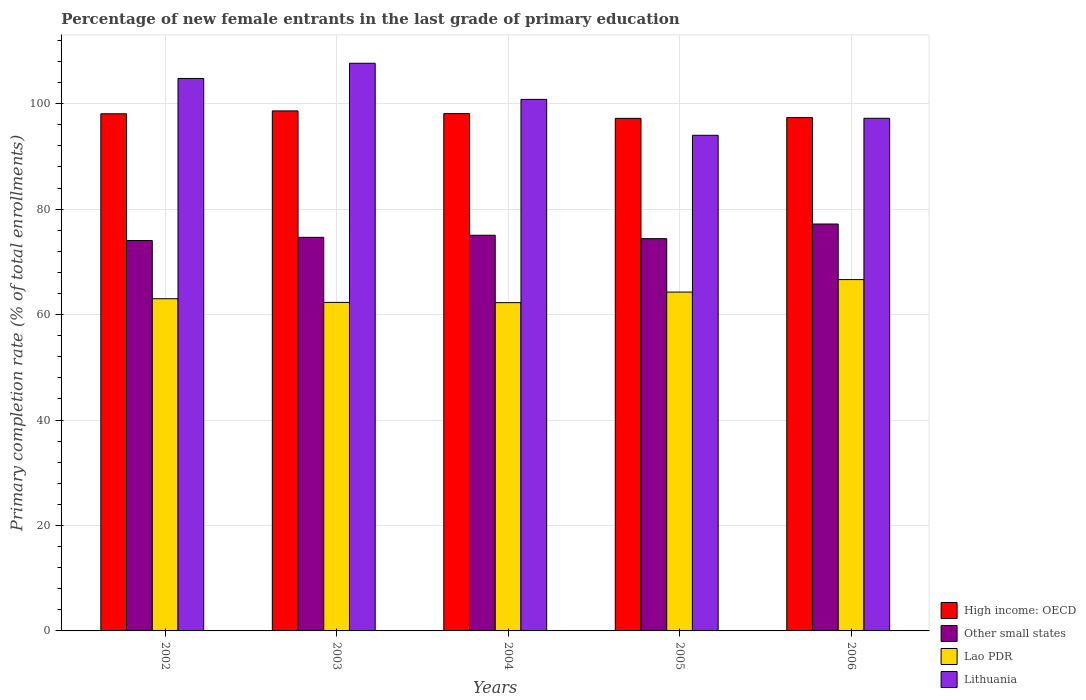How many bars are there on the 5th tick from the left?
Your answer should be compact. 4. How many bars are there on the 1st tick from the right?
Make the answer very short. 4. What is the label of the 5th group of bars from the left?
Your response must be concise. 2006. In how many cases, is the number of bars for a given year not equal to the number of legend labels?
Your response must be concise. 0. What is the percentage of new female entrants in Other small states in 2005?
Provide a short and direct response. 74.4. Across all years, what is the maximum percentage of new female entrants in Lao PDR?
Provide a succinct answer. 66.64. Across all years, what is the minimum percentage of new female entrants in High income: OECD?
Your answer should be compact. 97.22. In which year was the percentage of new female entrants in Other small states minimum?
Make the answer very short. 2002. What is the total percentage of new female entrants in Lao PDR in the graph?
Keep it short and to the point. 318.5. What is the difference between the percentage of new female entrants in Other small states in 2003 and that in 2006?
Keep it short and to the point. -2.53. What is the difference between the percentage of new female entrants in Other small states in 2003 and the percentage of new female entrants in Lao PDR in 2004?
Offer a very short reply. 12.39. What is the average percentage of new female entrants in Lithuania per year?
Your answer should be compact. 100.91. In the year 2006, what is the difference between the percentage of new female entrants in High income: OECD and percentage of new female entrants in Lithuania?
Your response must be concise. 0.13. In how many years, is the percentage of new female entrants in Lithuania greater than 8 %?
Give a very brief answer. 5. What is the ratio of the percentage of new female entrants in Other small states in 2003 to that in 2004?
Your response must be concise. 0.99. What is the difference between the highest and the second highest percentage of new female entrants in Other small states?
Offer a very short reply. 2.13. What is the difference between the highest and the lowest percentage of new female entrants in High income: OECD?
Your response must be concise. 1.41. Is it the case that in every year, the sum of the percentage of new female entrants in Other small states and percentage of new female entrants in Lao PDR is greater than the sum of percentage of new female entrants in Lithuania and percentage of new female entrants in High income: OECD?
Offer a very short reply. No. What does the 1st bar from the left in 2003 represents?
Give a very brief answer. High income: OECD. What does the 1st bar from the right in 2005 represents?
Keep it short and to the point. Lithuania. Is it the case that in every year, the sum of the percentage of new female entrants in Other small states and percentage of new female entrants in Lithuania is greater than the percentage of new female entrants in Lao PDR?
Offer a very short reply. Yes. How many bars are there?
Offer a terse response. 20. How many years are there in the graph?
Offer a terse response. 5. What is the difference between two consecutive major ticks on the Y-axis?
Provide a succinct answer. 20. Are the values on the major ticks of Y-axis written in scientific E-notation?
Offer a very short reply. No. Does the graph contain grids?
Your answer should be very brief. Yes. Where does the legend appear in the graph?
Your answer should be compact. Bottom right. How many legend labels are there?
Provide a short and direct response. 4. What is the title of the graph?
Offer a very short reply. Percentage of new female entrants in the last grade of primary education. What is the label or title of the Y-axis?
Offer a terse response. Primary completion rate (% of total enrollments). What is the Primary completion rate (% of total enrollments) of High income: OECD in 2002?
Your answer should be compact. 98.09. What is the Primary completion rate (% of total enrollments) in Other small states in 2002?
Offer a terse response. 74.05. What is the Primary completion rate (% of total enrollments) of Lao PDR in 2002?
Provide a short and direct response. 63.01. What is the Primary completion rate (% of total enrollments) in Lithuania in 2002?
Provide a short and direct response. 104.79. What is the Primary completion rate (% of total enrollments) of High income: OECD in 2003?
Give a very brief answer. 98.64. What is the Primary completion rate (% of total enrollments) in Other small states in 2003?
Provide a succinct answer. 74.66. What is the Primary completion rate (% of total enrollments) of Lao PDR in 2003?
Provide a short and direct response. 62.31. What is the Primary completion rate (% of total enrollments) in Lithuania in 2003?
Provide a short and direct response. 107.67. What is the Primary completion rate (% of total enrollments) of High income: OECD in 2004?
Your response must be concise. 98.12. What is the Primary completion rate (% of total enrollments) in Other small states in 2004?
Provide a short and direct response. 75.05. What is the Primary completion rate (% of total enrollments) in Lao PDR in 2004?
Offer a terse response. 62.27. What is the Primary completion rate (% of total enrollments) of Lithuania in 2004?
Offer a very short reply. 100.82. What is the Primary completion rate (% of total enrollments) of High income: OECD in 2005?
Your answer should be very brief. 97.22. What is the Primary completion rate (% of total enrollments) of Other small states in 2005?
Ensure brevity in your answer.  74.4. What is the Primary completion rate (% of total enrollments) in Lao PDR in 2005?
Keep it short and to the point. 64.27. What is the Primary completion rate (% of total enrollments) of Lithuania in 2005?
Your response must be concise. 94.01. What is the Primary completion rate (% of total enrollments) of High income: OECD in 2006?
Give a very brief answer. 97.37. What is the Primary completion rate (% of total enrollments) of Other small states in 2006?
Ensure brevity in your answer.  77.18. What is the Primary completion rate (% of total enrollments) of Lao PDR in 2006?
Make the answer very short. 66.64. What is the Primary completion rate (% of total enrollments) in Lithuania in 2006?
Offer a very short reply. 97.24. Across all years, what is the maximum Primary completion rate (% of total enrollments) of High income: OECD?
Provide a succinct answer. 98.64. Across all years, what is the maximum Primary completion rate (% of total enrollments) in Other small states?
Provide a succinct answer. 77.18. Across all years, what is the maximum Primary completion rate (% of total enrollments) of Lao PDR?
Make the answer very short. 66.64. Across all years, what is the maximum Primary completion rate (% of total enrollments) in Lithuania?
Offer a terse response. 107.67. Across all years, what is the minimum Primary completion rate (% of total enrollments) of High income: OECD?
Provide a short and direct response. 97.22. Across all years, what is the minimum Primary completion rate (% of total enrollments) in Other small states?
Keep it short and to the point. 74.05. Across all years, what is the minimum Primary completion rate (% of total enrollments) in Lao PDR?
Your answer should be very brief. 62.27. Across all years, what is the minimum Primary completion rate (% of total enrollments) of Lithuania?
Offer a terse response. 94.01. What is the total Primary completion rate (% of total enrollments) of High income: OECD in the graph?
Provide a succinct answer. 489.44. What is the total Primary completion rate (% of total enrollments) in Other small states in the graph?
Your answer should be compact. 375.34. What is the total Primary completion rate (% of total enrollments) of Lao PDR in the graph?
Make the answer very short. 318.5. What is the total Primary completion rate (% of total enrollments) of Lithuania in the graph?
Keep it short and to the point. 504.54. What is the difference between the Primary completion rate (% of total enrollments) of High income: OECD in 2002 and that in 2003?
Your response must be concise. -0.55. What is the difference between the Primary completion rate (% of total enrollments) of Other small states in 2002 and that in 2003?
Your response must be concise. -0.61. What is the difference between the Primary completion rate (% of total enrollments) of Lao PDR in 2002 and that in 2003?
Your answer should be very brief. 0.7. What is the difference between the Primary completion rate (% of total enrollments) of Lithuania in 2002 and that in 2003?
Keep it short and to the point. -2.88. What is the difference between the Primary completion rate (% of total enrollments) in High income: OECD in 2002 and that in 2004?
Offer a terse response. -0.03. What is the difference between the Primary completion rate (% of total enrollments) in Other small states in 2002 and that in 2004?
Your answer should be compact. -1. What is the difference between the Primary completion rate (% of total enrollments) in Lao PDR in 2002 and that in 2004?
Make the answer very short. 0.74. What is the difference between the Primary completion rate (% of total enrollments) in Lithuania in 2002 and that in 2004?
Make the answer very short. 3.97. What is the difference between the Primary completion rate (% of total enrollments) in High income: OECD in 2002 and that in 2005?
Your answer should be compact. 0.87. What is the difference between the Primary completion rate (% of total enrollments) in Other small states in 2002 and that in 2005?
Give a very brief answer. -0.35. What is the difference between the Primary completion rate (% of total enrollments) of Lao PDR in 2002 and that in 2005?
Your answer should be compact. -1.26. What is the difference between the Primary completion rate (% of total enrollments) in Lithuania in 2002 and that in 2005?
Your answer should be very brief. 10.78. What is the difference between the Primary completion rate (% of total enrollments) of High income: OECD in 2002 and that in 2006?
Your answer should be very brief. 0.72. What is the difference between the Primary completion rate (% of total enrollments) in Other small states in 2002 and that in 2006?
Your response must be concise. -3.14. What is the difference between the Primary completion rate (% of total enrollments) in Lao PDR in 2002 and that in 2006?
Your answer should be very brief. -3.63. What is the difference between the Primary completion rate (% of total enrollments) in Lithuania in 2002 and that in 2006?
Ensure brevity in your answer.  7.55. What is the difference between the Primary completion rate (% of total enrollments) in High income: OECD in 2003 and that in 2004?
Your response must be concise. 0.52. What is the difference between the Primary completion rate (% of total enrollments) of Other small states in 2003 and that in 2004?
Give a very brief answer. -0.4. What is the difference between the Primary completion rate (% of total enrollments) of Lao PDR in 2003 and that in 2004?
Provide a succinct answer. 0.05. What is the difference between the Primary completion rate (% of total enrollments) in Lithuania in 2003 and that in 2004?
Your answer should be very brief. 6.85. What is the difference between the Primary completion rate (% of total enrollments) in High income: OECD in 2003 and that in 2005?
Give a very brief answer. 1.41. What is the difference between the Primary completion rate (% of total enrollments) in Other small states in 2003 and that in 2005?
Your response must be concise. 0.25. What is the difference between the Primary completion rate (% of total enrollments) of Lao PDR in 2003 and that in 2005?
Provide a succinct answer. -1.96. What is the difference between the Primary completion rate (% of total enrollments) in Lithuania in 2003 and that in 2005?
Your response must be concise. 13.66. What is the difference between the Primary completion rate (% of total enrollments) in High income: OECD in 2003 and that in 2006?
Provide a succinct answer. 1.27. What is the difference between the Primary completion rate (% of total enrollments) in Other small states in 2003 and that in 2006?
Your answer should be very brief. -2.53. What is the difference between the Primary completion rate (% of total enrollments) in Lao PDR in 2003 and that in 2006?
Your answer should be compact. -4.33. What is the difference between the Primary completion rate (% of total enrollments) of Lithuania in 2003 and that in 2006?
Give a very brief answer. 10.44. What is the difference between the Primary completion rate (% of total enrollments) of High income: OECD in 2004 and that in 2005?
Provide a short and direct response. 0.9. What is the difference between the Primary completion rate (% of total enrollments) of Other small states in 2004 and that in 2005?
Provide a succinct answer. 0.65. What is the difference between the Primary completion rate (% of total enrollments) in Lao PDR in 2004 and that in 2005?
Provide a short and direct response. -2.01. What is the difference between the Primary completion rate (% of total enrollments) of Lithuania in 2004 and that in 2005?
Make the answer very short. 6.81. What is the difference between the Primary completion rate (% of total enrollments) in High income: OECD in 2004 and that in 2006?
Keep it short and to the point. 0.75. What is the difference between the Primary completion rate (% of total enrollments) in Other small states in 2004 and that in 2006?
Offer a terse response. -2.13. What is the difference between the Primary completion rate (% of total enrollments) in Lao PDR in 2004 and that in 2006?
Give a very brief answer. -4.37. What is the difference between the Primary completion rate (% of total enrollments) of Lithuania in 2004 and that in 2006?
Offer a very short reply. 3.58. What is the difference between the Primary completion rate (% of total enrollments) of High income: OECD in 2005 and that in 2006?
Provide a succinct answer. -0.15. What is the difference between the Primary completion rate (% of total enrollments) in Other small states in 2005 and that in 2006?
Offer a very short reply. -2.78. What is the difference between the Primary completion rate (% of total enrollments) in Lao PDR in 2005 and that in 2006?
Your answer should be very brief. -2.37. What is the difference between the Primary completion rate (% of total enrollments) in Lithuania in 2005 and that in 2006?
Your response must be concise. -3.23. What is the difference between the Primary completion rate (% of total enrollments) in High income: OECD in 2002 and the Primary completion rate (% of total enrollments) in Other small states in 2003?
Your answer should be very brief. 23.43. What is the difference between the Primary completion rate (% of total enrollments) in High income: OECD in 2002 and the Primary completion rate (% of total enrollments) in Lao PDR in 2003?
Provide a short and direct response. 35.78. What is the difference between the Primary completion rate (% of total enrollments) in High income: OECD in 2002 and the Primary completion rate (% of total enrollments) in Lithuania in 2003?
Provide a short and direct response. -9.58. What is the difference between the Primary completion rate (% of total enrollments) of Other small states in 2002 and the Primary completion rate (% of total enrollments) of Lao PDR in 2003?
Make the answer very short. 11.74. What is the difference between the Primary completion rate (% of total enrollments) of Other small states in 2002 and the Primary completion rate (% of total enrollments) of Lithuania in 2003?
Your answer should be very brief. -33.63. What is the difference between the Primary completion rate (% of total enrollments) of Lao PDR in 2002 and the Primary completion rate (% of total enrollments) of Lithuania in 2003?
Ensure brevity in your answer.  -44.66. What is the difference between the Primary completion rate (% of total enrollments) in High income: OECD in 2002 and the Primary completion rate (% of total enrollments) in Other small states in 2004?
Your answer should be very brief. 23.04. What is the difference between the Primary completion rate (% of total enrollments) of High income: OECD in 2002 and the Primary completion rate (% of total enrollments) of Lao PDR in 2004?
Provide a succinct answer. 35.82. What is the difference between the Primary completion rate (% of total enrollments) in High income: OECD in 2002 and the Primary completion rate (% of total enrollments) in Lithuania in 2004?
Keep it short and to the point. -2.73. What is the difference between the Primary completion rate (% of total enrollments) in Other small states in 2002 and the Primary completion rate (% of total enrollments) in Lao PDR in 2004?
Offer a very short reply. 11.78. What is the difference between the Primary completion rate (% of total enrollments) in Other small states in 2002 and the Primary completion rate (% of total enrollments) in Lithuania in 2004?
Provide a succinct answer. -26.77. What is the difference between the Primary completion rate (% of total enrollments) of Lao PDR in 2002 and the Primary completion rate (% of total enrollments) of Lithuania in 2004?
Ensure brevity in your answer.  -37.81. What is the difference between the Primary completion rate (% of total enrollments) in High income: OECD in 2002 and the Primary completion rate (% of total enrollments) in Other small states in 2005?
Your answer should be very brief. 23.69. What is the difference between the Primary completion rate (% of total enrollments) of High income: OECD in 2002 and the Primary completion rate (% of total enrollments) of Lao PDR in 2005?
Offer a very short reply. 33.82. What is the difference between the Primary completion rate (% of total enrollments) of High income: OECD in 2002 and the Primary completion rate (% of total enrollments) of Lithuania in 2005?
Keep it short and to the point. 4.08. What is the difference between the Primary completion rate (% of total enrollments) of Other small states in 2002 and the Primary completion rate (% of total enrollments) of Lao PDR in 2005?
Give a very brief answer. 9.78. What is the difference between the Primary completion rate (% of total enrollments) of Other small states in 2002 and the Primary completion rate (% of total enrollments) of Lithuania in 2005?
Provide a succinct answer. -19.96. What is the difference between the Primary completion rate (% of total enrollments) of Lao PDR in 2002 and the Primary completion rate (% of total enrollments) of Lithuania in 2005?
Provide a succinct answer. -31. What is the difference between the Primary completion rate (% of total enrollments) in High income: OECD in 2002 and the Primary completion rate (% of total enrollments) in Other small states in 2006?
Your response must be concise. 20.91. What is the difference between the Primary completion rate (% of total enrollments) of High income: OECD in 2002 and the Primary completion rate (% of total enrollments) of Lao PDR in 2006?
Ensure brevity in your answer.  31.45. What is the difference between the Primary completion rate (% of total enrollments) of High income: OECD in 2002 and the Primary completion rate (% of total enrollments) of Lithuania in 2006?
Your answer should be compact. 0.85. What is the difference between the Primary completion rate (% of total enrollments) in Other small states in 2002 and the Primary completion rate (% of total enrollments) in Lao PDR in 2006?
Ensure brevity in your answer.  7.41. What is the difference between the Primary completion rate (% of total enrollments) in Other small states in 2002 and the Primary completion rate (% of total enrollments) in Lithuania in 2006?
Give a very brief answer. -23.19. What is the difference between the Primary completion rate (% of total enrollments) of Lao PDR in 2002 and the Primary completion rate (% of total enrollments) of Lithuania in 2006?
Ensure brevity in your answer.  -34.23. What is the difference between the Primary completion rate (% of total enrollments) in High income: OECD in 2003 and the Primary completion rate (% of total enrollments) in Other small states in 2004?
Your answer should be very brief. 23.58. What is the difference between the Primary completion rate (% of total enrollments) in High income: OECD in 2003 and the Primary completion rate (% of total enrollments) in Lao PDR in 2004?
Offer a very short reply. 36.37. What is the difference between the Primary completion rate (% of total enrollments) in High income: OECD in 2003 and the Primary completion rate (% of total enrollments) in Lithuania in 2004?
Offer a very short reply. -2.18. What is the difference between the Primary completion rate (% of total enrollments) of Other small states in 2003 and the Primary completion rate (% of total enrollments) of Lao PDR in 2004?
Give a very brief answer. 12.39. What is the difference between the Primary completion rate (% of total enrollments) of Other small states in 2003 and the Primary completion rate (% of total enrollments) of Lithuania in 2004?
Your answer should be compact. -26.17. What is the difference between the Primary completion rate (% of total enrollments) in Lao PDR in 2003 and the Primary completion rate (% of total enrollments) in Lithuania in 2004?
Make the answer very short. -38.51. What is the difference between the Primary completion rate (% of total enrollments) in High income: OECD in 2003 and the Primary completion rate (% of total enrollments) in Other small states in 2005?
Give a very brief answer. 24.24. What is the difference between the Primary completion rate (% of total enrollments) in High income: OECD in 2003 and the Primary completion rate (% of total enrollments) in Lao PDR in 2005?
Provide a short and direct response. 34.37. What is the difference between the Primary completion rate (% of total enrollments) in High income: OECD in 2003 and the Primary completion rate (% of total enrollments) in Lithuania in 2005?
Offer a very short reply. 4.63. What is the difference between the Primary completion rate (% of total enrollments) in Other small states in 2003 and the Primary completion rate (% of total enrollments) in Lao PDR in 2005?
Give a very brief answer. 10.38. What is the difference between the Primary completion rate (% of total enrollments) in Other small states in 2003 and the Primary completion rate (% of total enrollments) in Lithuania in 2005?
Provide a succinct answer. -19.36. What is the difference between the Primary completion rate (% of total enrollments) in Lao PDR in 2003 and the Primary completion rate (% of total enrollments) in Lithuania in 2005?
Your answer should be very brief. -31.7. What is the difference between the Primary completion rate (% of total enrollments) in High income: OECD in 2003 and the Primary completion rate (% of total enrollments) in Other small states in 2006?
Offer a terse response. 21.45. What is the difference between the Primary completion rate (% of total enrollments) of High income: OECD in 2003 and the Primary completion rate (% of total enrollments) of Lao PDR in 2006?
Give a very brief answer. 32. What is the difference between the Primary completion rate (% of total enrollments) in High income: OECD in 2003 and the Primary completion rate (% of total enrollments) in Lithuania in 2006?
Give a very brief answer. 1.4. What is the difference between the Primary completion rate (% of total enrollments) of Other small states in 2003 and the Primary completion rate (% of total enrollments) of Lao PDR in 2006?
Keep it short and to the point. 8.02. What is the difference between the Primary completion rate (% of total enrollments) of Other small states in 2003 and the Primary completion rate (% of total enrollments) of Lithuania in 2006?
Provide a succinct answer. -22.58. What is the difference between the Primary completion rate (% of total enrollments) of Lao PDR in 2003 and the Primary completion rate (% of total enrollments) of Lithuania in 2006?
Make the answer very short. -34.92. What is the difference between the Primary completion rate (% of total enrollments) in High income: OECD in 2004 and the Primary completion rate (% of total enrollments) in Other small states in 2005?
Provide a succinct answer. 23.72. What is the difference between the Primary completion rate (% of total enrollments) of High income: OECD in 2004 and the Primary completion rate (% of total enrollments) of Lao PDR in 2005?
Offer a very short reply. 33.85. What is the difference between the Primary completion rate (% of total enrollments) of High income: OECD in 2004 and the Primary completion rate (% of total enrollments) of Lithuania in 2005?
Offer a very short reply. 4.11. What is the difference between the Primary completion rate (% of total enrollments) of Other small states in 2004 and the Primary completion rate (% of total enrollments) of Lao PDR in 2005?
Your answer should be very brief. 10.78. What is the difference between the Primary completion rate (% of total enrollments) in Other small states in 2004 and the Primary completion rate (% of total enrollments) in Lithuania in 2005?
Offer a terse response. -18.96. What is the difference between the Primary completion rate (% of total enrollments) in Lao PDR in 2004 and the Primary completion rate (% of total enrollments) in Lithuania in 2005?
Keep it short and to the point. -31.75. What is the difference between the Primary completion rate (% of total enrollments) in High income: OECD in 2004 and the Primary completion rate (% of total enrollments) in Other small states in 2006?
Give a very brief answer. 20.94. What is the difference between the Primary completion rate (% of total enrollments) of High income: OECD in 2004 and the Primary completion rate (% of total enrollments) of Lao PDR in 2006?
Give a very brief answer. 31.48. What is the difference between the Primary completion rate (% of total enrollments) in High income: OECD in 2004 and the Primary completion rate (% of total enrollments) in Lithuania in 2006?
Make the answer very short. 0.88. What is the difference between the Primary completion rate (% of total enrollments) in Other small states in 2004 and the Primary completion rate (% of total enrollments) in Lao PDR in 2006?
Your response must be concise. 8.41. What is the difference between the Primary completion rate (% of total enrollments) of Other small states in 2004 and the Primary completion rate (% of total enrollments) of Lithuania in 2006?
Offer a terse response. -22.18. What is the difference between the Primary completion rate (% of total enrollments) of Lao PDR in 2004 and the Primary completion rate (% of total enrollments) of Lithuania in 2006?
Make the answer very short. -34.97. What is the difference between the Primary completion rate (% of total enrollments) in High income: OECD in 2005 and the Primary completion rate (% of total enrollments) in Other small states in 2006?
Provide a succinct answer. 20.04. What is the difference between the Primary completion rate (% of total enrollments) of High income: OECD in 2005 and the Primary completion rate (% of total enrollments) of Lao PDR in 2006?
Your response must be concise. 30.58. What is the difference between the Primary completion rate (% of total enrollments) in High income: OECD in 2005 and the Primary completion rate (% of total enrollments) in Lithuania in 2006?
Your answer should be very brief. -0.01. What is the difference between the Primary completion rate (% of total enrollments) of Other small states in 2005 and the Primary completion rate (% of total enrollments) of Lao PDR in 2006?
Provide a succinct answer. 7.76. What is the difference between the Primary completion rate (% of total enrollments) in Other small states in 2005 and the Primary completion rate (% of total enrollments) in Lithuania in 2006?
Provide a succinct answer. -22.84. What is the difference between the Primary completion rate (% of total enrollments) of Lao PDR in 2005 and the Primary completion rate (% of total enrollments) of Lithuania in 2006?
Ensure brevity in your answer.  -32.97. What is the average Primary completion rate (% of total enrollments) of High income: OECD per year?
Offer a very short reply. 97.89. What is the average Primary completion rate (% of total enrollments) in Other small states per year?
Your answer should be very brief. 75.07. What is the average Primary completion rate (% of total enrollments) in Lao PDR per year?
Your answer should be compact. 63.7. What is the average Primary completion rate (% of total enrollments) in Lithuania per year?
Your answer should be compact. 100.91. In the year 2002, what is the difference between the Primary completion rate (% of total enrollments) in High income: OECD and Primary completion rate (% of total enrollments) in Other small states?
Your response must be concise. 24.04. In the year 2002, what is the difference between the Primary completion rate (% of total enrollments) of High income: OECD and Primary completion rate (% of total enrollments) of Lao PDR?
Offer a very short reply. 35.08. In the year 2002, what is the difference between the Primary completion rate (% of total enrollments) of High income: OECD and Primary completion rate (% of total enrollments) of Lithuania?
Give a very brief answer. -6.7. In the year 2002, what is the difference between the Primary completion rate (% of total enrollments) in Other small states and Primary completion rate (% of total enrollments) in Lao PDR?
Provide a succinct answer. 11.04. In the year 2002, what is the difference between the Primary completion rate (% of total enrollments) of Other small states and Primary completion rate (% of total enrollments) of Lithuania?
Your response must be concise. -30.74. In the year 2002, what is the difference between the Primary completion rate (% of total enrollments) of Lao PDR and Primary completion rate (% of total enrollments) of Lithuania?
Give a very brief answer. -41.78. In the year 2003, what is the difference between the Primary completion rate (% of total enrollments) in High income: OECD and Primary completion rate (% of total enrollments) in Other small states?
Your response must be concise. 23.98. In the year 2003, what is the difference between the Primary completion rate (% of total enrollments) of High income: OECD and Primary completion rate (% of total enrollments) of Lao PDR?
Provide a short and direct response. 36.32. In the year 2003, what is the difference between the Primary completion rate (% of total enrollments) in High income: OECD and Primary completion rate (% of total enrollments) in Lithuania?
Your answer should be very brief. -9.04. In the year 2003, what is the difference between the Primary completion rate (% of total enrollments) in Other small states and Primary completion rate (% of total enrollments) in Lao PDR?
Ensure brevity in your answer.  12.34. In the year 2003, what is the difference between the Primary completion rate (% of total enrollments) of Other small states and Primary completion rate (% of total enrollments) of Lithuania?
Keep it short and to the point. -33.02. In the year 2003, what is the difference between the Primary completion rate (% of total enrollments) in Lao PDR and Primary completion rate (% of total enrollments) in Lithuania?
Offer a terse response. -45.36. In the year 2004, what is the difference between the Primary completion rate (% of total enrollments) of High income: OECD and Primary completion rate (% of total enrollments) of Other small states?
Your answer should be compact. 23.07. In the year 2004, what is the difference between the Primary completion rate (% of total enrollments) of High income: OECD and Primary completion rate (% of total enrollments) of Lao PDR?
Provide a short and direct response. 35.86. In the year 2004, what is the difference between the Primary completion rate (% of total enrollments) in High income: OECD and Primary completion rate (% of total enrollments) in Lithuania?
Provide a succinct answer. -2.7. In the year 2004, what is the difference between the Primary completion rate (% of total enrollments) of Other small states and Primary completion rate (% of total enrollments) of Lao PDR?
Keep it short and to the point. 12.79. In the year 2004, what is the difference between the Primary completion rate (% of total enrollments) in Other small states and Primary completion rate (% of total enrollments) in Lithuania?
Your answer should be very brief. -25.77. In the year 2004, what is the difference between the Primary completion rate (% of total enrollments) of Lao PDR and Primary completion rate (% of total enrollments) of Lithuania?
Keep it short and to the point. -38.56. In the year 2005, what is the difference between the Primary completion rate (% of total enrollments) in High income: OECD and Primary completion rate (% of total enrollments) in Other small states?
Ensure brevity in your answer.  22.82. In the year 2005, what is the difference between the Primary completion rate (% of total enrollments) of High income: OECD and Primary completion rate (% of total enrollments) of Lao PDR?
Your answer should be very brief. 32.95. In the year 2005, what is the difference between the Primary completion rate (% of total enrollments) of High income: OECD and Primary completion rate (% of total enrollments) of Lithuania?
Provide a succinct answer. 3.21. In the year 2005, what is the difference between the Primary completion rate (% of total enrollments) of Other small states and Primary completion rate (% of total enrollments) of Lao PDR?
Offer a terse response. 10.13. In the year 2005, what is the difference between the Primary completion rate (% of total enrollments) in Other small states and Primary completion rate (% of total enrollments) in Lithuania?
Your answer should be compact. -19.61. In the year 2005, what is the difference between the Primary completion rate (% of total enrollments) in Lao PDR and Primary completion rate (% of total enrollments) in Lithuania?
Your response must be concise. -29.74. In the year 2006, what is the difference between the Primary completion rate (% of total enrollments) in High income: OECD and Primary completion rate (% of total enrollments) in Other small states?
Your response must be concise. 20.19. In the year 2006, what is the difference between the Primary completion rate (% of total enrollments) in High income: OECD and Primary completion rate (% of total enrollments) in Lao PDR?
Make the answer very short. 30.73. In the year 2006, what is the difference between the Primary completion rate (% of total enrollments) in High income: OECD and Primary completion rate (% of total enrollments) in Lithuania?
Provide a short and direct response. 0.13. In the year 2006, what is the difference between the Primary completion rate (% of total enrollments) in Other small states and Primary completion rate (% of total enrollments) in Lao PDR?
Keep it short and to the point. 10.54. In the year 2006, what is the difference between the Primary completion rate (% of total enrollments) of Other small states and Primary completion rate (% of total enrollments) of Lithuania?
Give a very brief answer. -20.05. In the year 2006, what is the difference between the Primary completion rate (% of total enrollments) of Lao PDR and Primary completion rate (% of total enrollments) of Lithuania?
Keep it short and to the point. -30.6. What is the ratio of the Primary completion rate (% of total enrollments) in High income: OECD in 2002 to that in 2003?
Provide a succinct answer. 0.99. What is the ratio of the Primary completion rate (% of total enrollments) of Other small states in 2002 to that in 2003?
Give a very brief answer. 0.99. What is the ratio of the Primary completion rate (% of total enrollments) of Lao PDR in 2002 to that in 2003?
Give a very brief answer. 1.01. What is the ratio of the Primary completion rate (% of total enrollments) of Lithuania in 2002 to that in 2003?
Ensure brevity in your answer.  0.97. What is the ratio of the Primary completion rate (% of total enrollments) in High income: OECD in 2002 to that in 2004?
Offer a terse response. 1. What is the ratio of the Primary completion rate (% of total enrollments) of Other small states in 2002 to that in 2004?
Keep it short and to the point. 0.99. What is the ratio of the Primary completion rate (% of total enrollments) of Lao PDR in 2002 to that in 2004?
Your answer should be very brief. 1.01. What is the ratio of the Primary completion rate (% of total enrollments) of Lithuania in 2002 to that in 2004?
Ensure brevity in your answer.  1.04. What is the ratio of the Primary completion rate (% of total enrollments) of High income: OECD in 2002 to that in 2005?
Your answer should be very brief. 1.01. What is the ratio of the Primary completion rate (% of total enrollments) of Lao PDR in 2002 to that in 2005?
Your answer should be very brief. 0.98. What is the ratio of the Primary completion rate (% of total enrollments) of Lithuania in 2002 to that in 2005?
Keep it short and to the point. 1.11. What is the ratio of the Primary completion rate (% of total enrollments) of High income: OECD in 2002 to that in 2006?
Give a very brief answer. 1.01. What is the ratio of the Primary completion rate (% of total enrollments) of Other small states in 2002 to that in 2006?
Your answer should be compact. 0.96. What is the ratio of the Primary completion rate (% of total enrollments) of Lao PDR in 2002 to that in 2006?
Your answer should be compact. 0.95. What is the ratio of the Primary completion rate (% of total enrollments) in Lithuania in 2002 to that in 2006?
Give a very brief answer. 1.08. What is the ratio of the Primary completion rate (% of total enrollments) of Other small states in 2003 to that in 2004?
Offer a very short reply. 0.99. What is the ratio of the Primary completion rate (% of total enrollments) in Lithuania in 2003 to that in 2004?
Offer a very short reply. 1.07. What is the ratio of the Primary completion rate (% of total enrollments) of High income: OECD in 2003 to that in 2005?
Give a very brief answer. 1.01. What is the ratio of the Primary completion rate (% of total enrollments) in Lao PDR in 2003 to that in 2005?
Offer a terse response. 0.97. What is the ratio of the Primary completion rate (% of total enrollments) in Lithuania in 2003 to that in 2005?
Keep it short and to the point. 1.15. What is the ratio of the Primary completion rate (% of total enrollments) in Other small states in 2003 to that in 2006?
Your answer should be compact. 0.97. What is the ratio of the Primary completion rate (% of total enrollments) in Lao PDR in 2003 to that in 2006?
Your answer should be very brief. 0.94. What is the ratio of the Primary completion rate (% of total enrollments) in Lithuania in 2003 to that in 2006?
Offer a very short reply. 1.11. What is the ratio of the Primary completion rate (% of total enrollments) of High income: OECD in 2004 to that in 2005?
Make the answer very short. 1.01. What is the ratio of the Primary completion rate (% of total enrollments) in Other small states in 2004 to that in 2005?
Offer a terse response. 1.01. What is the ratio of the Primary completion rate (% of total enrollments) in Lao PDR in 2004 to that in 2005?
Offer a very short reply. 0.97. What is the ratio of the Primary completion rate (% of total enrollments) of Lithuania in 2004 to that in 2005?
Keep it short and to the point. 1.07. What is the ratio of the Primary completion rate (% of total enrollments) in High income: OECD in 2004 to that in 2006?
Offer a very short reply. 1.01. What is the ratio of the Primary completion rate (% of total enrollments) of Other small states in 2004 to that in 2006?
Your answer should be compact. 0.97. What is the ratio of the Primary completion rate (% of total enrollments) in Lao PDR in 2004 to that in 2006?
Keep it short and to the point. 0.93. What is the ratio of the Primary completion rate (% of total enrollments) of Lithuania in 2004 to that in 2006?
Make the answer very short. 1.04. What is the ratio of the Primary completion rate (% of total enrollments) of High income: OECD in 2005 to that in 2006?
Ensure brevity in your answer.  1. What is the ratio of the Primary completion rate (% of total enrollments) of Other small states in 2005 to that in 2006?
Make the answer very short. 0.96. What is the ratio of the Primary completion rate (% of total enrollments) of Lao PDR in 2005 to that in 2006?
Your answer should be very brief. 0.96. What is the ratio of the Primary completion rate (% of total enrollments) of Lithuania in 2005 to that in 2006?
Make the answer very short. 0.97. What is the difference between the highest and the second highest Primary completion rate (% of total enrollments) in High income: OECD?
Ensure brevity in your answer.  0.52. What is the difference between the highest and the second highest Primary completion rate (% of total enrollments) in Other small states?
Give a very brief answer. 2.13. What is the difference between the highest and the second highest Primary completion rate (% of total enrollments) of Lao PDR?
Make the answer very short. 2.37. What is the difference between the highest and the second highest Primary completion rate (% of total enrollments) of Lithuania?
Your answer should be compact. 2.88. What is the difference between the highest and the lowest Primary completion rate (% of total enrollments) in High income: OECD?
Provide a short and direct response. 1.41. What is the difference between the highest and the lowest Primary completion rate (% of total enrollments) in Other small states?
Give a very brief answer. 3.14. What is the difference between the highest and the lowest Primary completion rate (% of total enrollments) in Lao PDR?
Make the answer very short. 4.37. What is the difference between the highest and the lowest Primary completion rate (% of total enrollments) of Lithuania?
Make the answer very short. 13.66. 